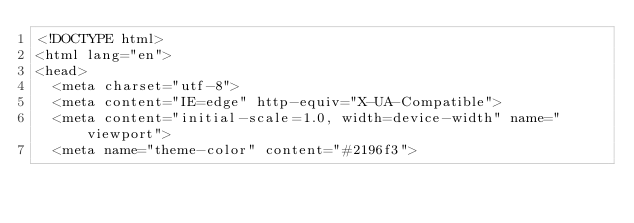<code> <loc_0><loc_0><loc_500><loc_500><_HTML_><!DOCTYPE html>
<html lang="en">
<head>
	<meta charset="utf-8">
	<meta content="IE=edge" http-equiv="X-UA-Compatible">
	<meta content="initial-scale=1.0, width=device-width" name="viewport">
	<meta name="theme-color" content="#2196f3"></code> 